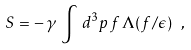<formula> <loc_0><loc_0><loc_500><loc_500>S = - \, \gamma \, \int \, d ^ { 3 } p \, f \, \Lambda ( f / \epsilon ) \ ,</formula> 